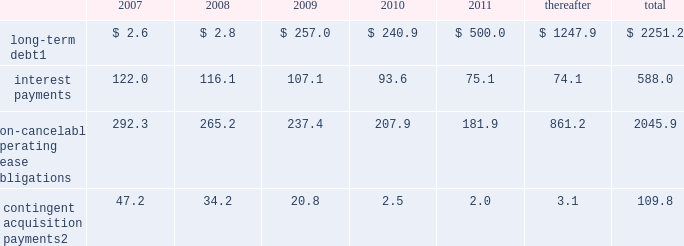Credit agency ratings our long-term debt credit ratings as of february 16 , 2007 were ba3 with negative outlook , b creditwatch negative and b with negative outlook , as reported by moody 2019s investors service , standard & poor 2019s and fitch ratings , respectively .
A downgrade in our credit ratings could adversely affect our ability to access capital and could result in more stringent covenants and higher interest rates under the terms of any new indebtedness .
Contractual obligations the following summarizes our estimated contractual obligations at december 31 , 2006 , and their effect on our liquidity and cash flow in future periods: .
Contingent acquisition payments 2 47.2 34.2 20.8 2.5 2.0 3.1 109.8 1 holders of our $ 400.0 4.50% ( 4.50 % ) notes may require us to repurchase their notes for cash at par in march 2008 .
These notes will mature in 2023 if not converted or repurchased .
2 we have structured certain acquisitions with additional contingent purchase price obligations in order to reduce the potential risk associated with negative future performance of the acquired entity .
All payments are contingent upon achieving projected operating performance targets and satisfying other conditions specified in the related agreements and are subject to revisions as the earn-out periods progress .
See note 18 to the consolidated financial statements for further information .
We have not included obligations under our pension and postretirement benefit plans in the contractual obligations table .
Our funding policy regarding our funded pension plan is to contribute amounts necessary to satisfy minimum pension funding requirements plus such additional amounts from time to time as are determined to be appropriate to improve the plans 2019 funded status .
The funded status of our pension plans is dependent upon many factors , including returns on invested assets , level of market interest rates and levels of voluntary contributions to the plans .
Declines in long-term interest rates have had a negative impact on the funded status of the plans .
For 2007 , we do not expect to contribute to our domestic pension plans , and expect to contribute $ 20.6 to our foreign pension plans .
We have not included our deferred tax obligations in the contractual obligations table as the timing of any future payments in relation to these obligations is uncertain .
Derivatives and hedging activities we periodically enter into interest rate swap agreements and forward contracts to manage exposure to interest rate fluctuations and to mitigate foreign exchange volatility .
In may of 2005 , we terminated all of our long-term interest rate swap agreements covering the $ 350.0 6.25% ( 6.25 % ) senior unsecured notes and $ 150.0 of the $ 500.0 7.25% ( 7.25 % ) senior unsecured notes .
In connection with the interest rate swap termination , our net cash receipts were $ 1.1 , which is recorded as an offset to interest expense over the remaining life of the related debt .
We have entered into foreign currency transactions in which various foreign currencies are bought or sold forward .
These contracts were entered into to meet currency requirements arising from specific transactions .
The changes in value of these forward contracts have been recorded in other income or expense .
As of december 31 , 2006 and 2005 , we had contracts covering $ 0.2 and $ 6.2 , respectively , of notional amount of currency and the fair value of the forward contracts was negligible .
The terms of the 4.50% ( 4.50 % ) notes include two embedded derivative instruments and the terms of our 4.25% ( 4.25 % ) notes and our series b preferred stock each include one embedded derivative instrument .
The fair value of these derivatives on december 31 , 2006 was negligible .
The interpublic group of companies , inc .
And subsidiaries management 2019s discussion and analysis of financial condition and results of operations 2014 ( continued ) ( amounts in millions , except per share amounts ) %%transmsg*** transmitting job : y31000 pcn : 036000000 ***%%pcmsg|36 |00005|yes|no|02/28/2007 01:12|0|0|page is valid , no graphics -- color : d| .
What is the total expected cash payments for obligations in 2007? 
Computations: (((2.6 + 122.0) + 292.3) + 47.2)
Answer: 464.1. 